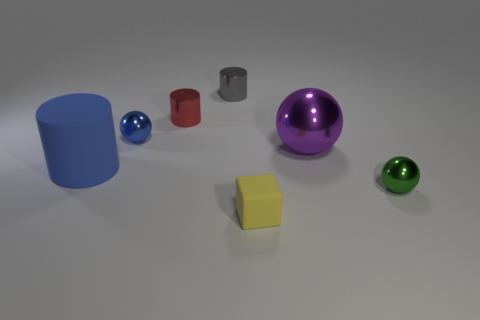There is a small thing that is the same color as the rubber cylinder; what is its material?
Provide a succinct answer. Metal. What is the shape of the metallic object that is in front of the purple ball?
Offer a terse response. Sphere. How many small red objects are there?
Your answer should be compact. 1. There is a thing that is made of the same material as the small yellow block; what is its color?
Offer a very short reply. Blue. What number of large objects are either blue rubber things or green metallic things?
Give a very brief answer. 1. How many shiny objects are right of the tiny gray metal thing?
Your response must be concise. 2. There is a big thing that is the same shape as the tiny red thing; what is its color?
Your response must be concise. Blue. How many metal objects are yellow cubes or red things?
Provide a short and direct response. 1. Are there any large cylinders that are right of the big object that is behind the rubber object behind the green metal ball?
Offer a very short reply. No. The large cylinder is what color?
Make the answer very short. Blue. 